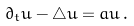Convert formula to latex. <formula><loc_0><loc_0><loc_500><loc_500>\partial _ { t } u - \triangle u = a u \, .</formula> 